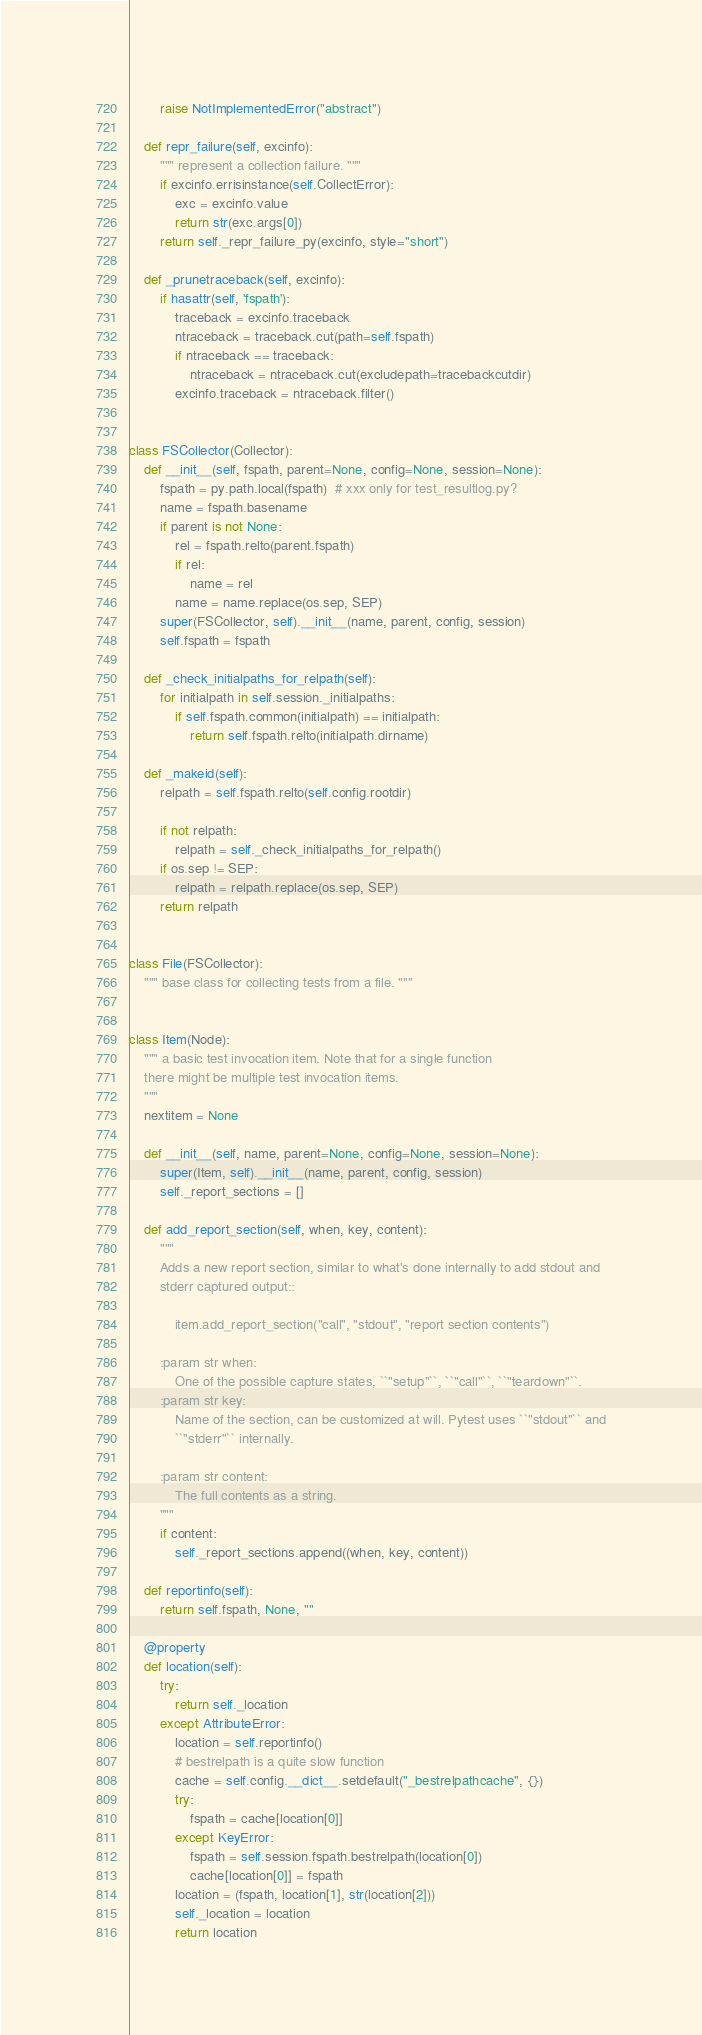<code> <loc_0><loc_0><loc_500><loc_500><_Python_>        raise NotImplementedError("abstract")

    def repr_failure(self, excinfo):
        """ represent a collection failure. """
        if excinfo.errisinstance(self.CollectError):
            exc = excinfo.value
            return str(exc.args[0])
        return self._repr_failure_py(excinfo, style="short")

    def _prunetraceback(self, excinfo):
        if hasattr(self, 'fspath'):
            traceback = excinfo.traceback
            ntraceback = traceback.cut(path=self.fspath)
            if ntraceback == traceback:
                ntraceback = ntraceback.cut(excludepath=tracebackcutdir)
            excinfo.traceback = ntraceback.filter()


class FSCollector(Collector):
    def __init__(self, fspath, parent=None, config=None, session=None):
        fspath = py.path.local(fspath)  # xxx only for test_resultlog.py?
        name = fspath.basename
        if parent is not None:
            rel = fspath.relto(parent.fspath)
            if rel:
                name = rel
            name = name.replace(os.sep, SEP)
        super(FSCollector, self).__init__(name, parent, config, session)
        self.fspath = fspath

    def _check_initialpaths_for_relpath(self):
        for initialpath in self.session._initialpaths:
            if self.fspath.common(initialpath) == initialpath:
                return self.fspath.relto(initialpath.dirname)

    def _makeid(self):
        relpath = self.fspath.relto(self.config.rootdir)

        if not relpath:
            relpath = self._check_initialpaths_for_relpath()
        if os.sep != SEP:
            relpath = relpath.replace(os.sep, SEP)
        return relpath


class File(FSCollector):
    """ base class for collecting tests from a file. """


class Item(Node):
    """ a basic test invocation item. Note that for a single function
    there might be multiple test invocation items.
    """
    nextitem = None

    def __init__(self, name, parent=None, config=None, session=None):
        super(Item, self).__init__(name, parent, config, session)
        self._report_sections = []

    def add_report_section(self, when, key, content):
        """
        Adds a new report section, similar to what's done internally to add stdout and
        stderr captured output::

            item.add_report_section("call", "stdout", "report section contents")

        :param str when:
            One of the possible capture states, ``"setup"``, ``"call"``, ``"teardown"``.
        :param str key:
            Name of the section, can be customized at will. Pytest uses ``"stdout"`` and
            ``"stderr"`` internally.

        :param str content:
            The full contents as a string.
        """
        if content:
            self._report_sections.append((when, key, content))

    def reportinfo(self):
        return self.fspath, None, ""

    @property
    def location(self):
        try:
            return self._location
        except AttributeError:
            location = self.reportinfo()
            # bestrelpath is a quite slow function
            cache = self.config.__dict__.setdefault("_bestrelpathcache", {})
            try:
                fspath = cache[location[0]]
            except KeyError:
                fspath = self.session.fspath.bestrelpath(location[0])
                cache[location[0]] = fspath
            location = (fspath, location[1], str(location[2]))
            self._location = location
            return location
</code> 